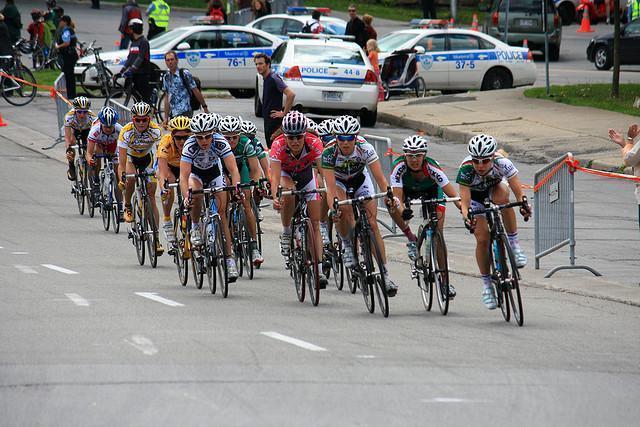How many police cars are in this picture?
Give a very brief answer. 4. How many cars can be seen?
Give a very brief answer. 4. How many bicycles are in the photo?
Give a very brief answer. 5. How many people are in the photo?
Give a very brief answer. 8. How many toilet rolls are reflected in the mirror?
Give a very brief answer. 0. 